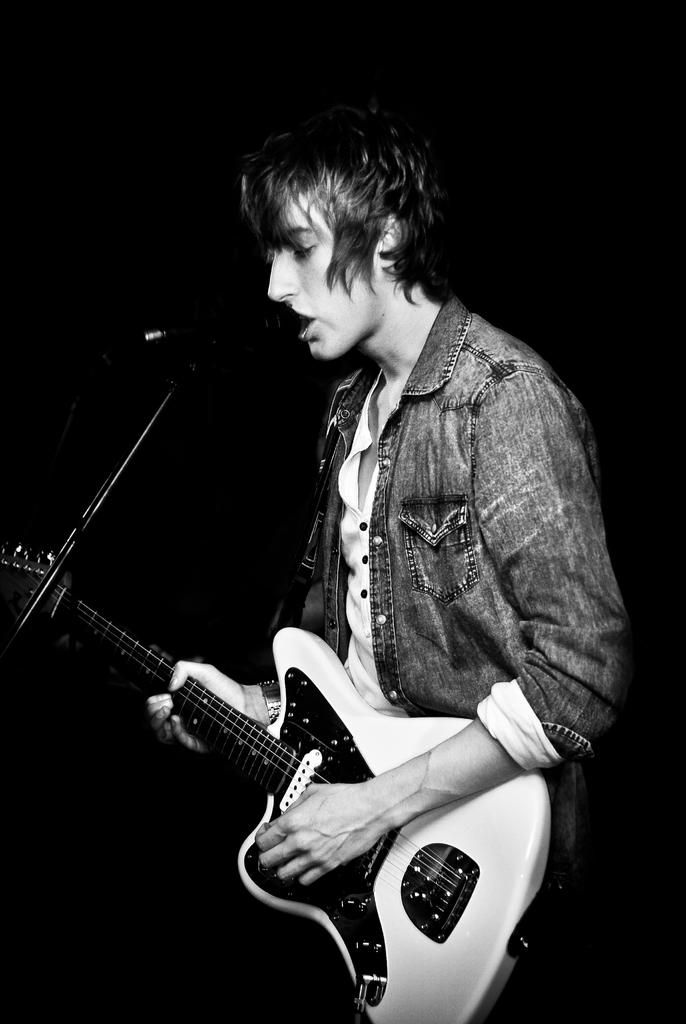What is the man in the image doing? The man is singing a song. What is the man wearing in the image? The man is wearing a jacket. What instrument is the man holding in the image? The man is holding a guitar in his hand. What can be seen in the background of the image? The background of the image is black. What type of joke does the man's aunt tell in the image? There is no mention of an aunt or a joke in the image; the man is singing a song while holding a guitar. 